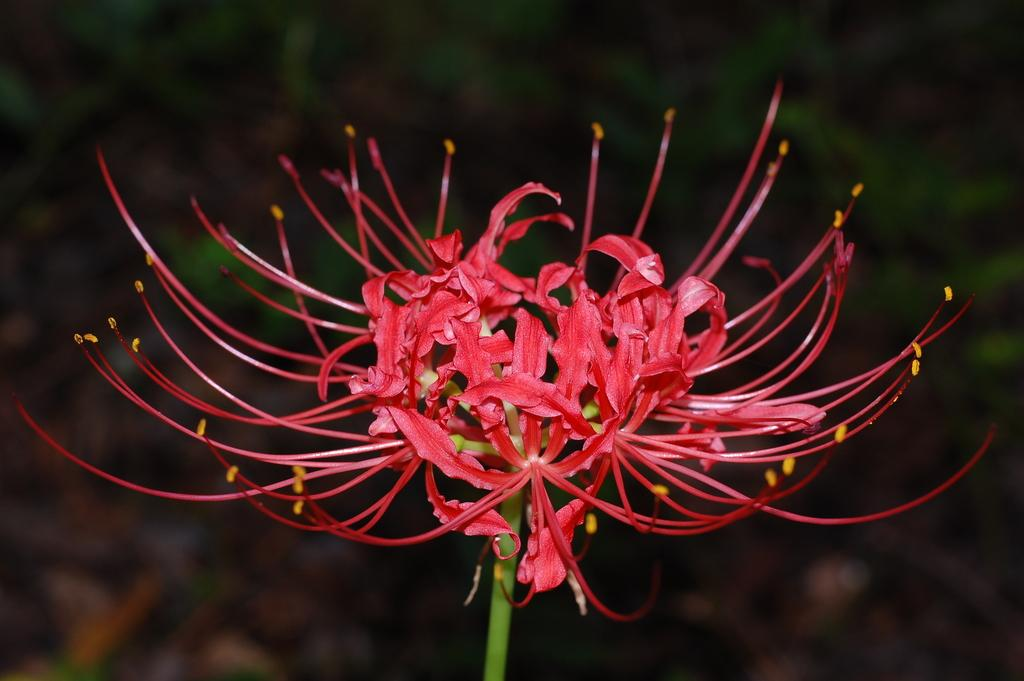What type of flower is in the image? There is a pink color flower in the image. Where is the flower located in the image? The flower is in the middle of the image. What can be observed about the background of the image? The background of the image is blurred. What type of organization is responsible for the egg in the image? There is no egg present in the image, so it is not possible to determine which organization might be responsible for it. 